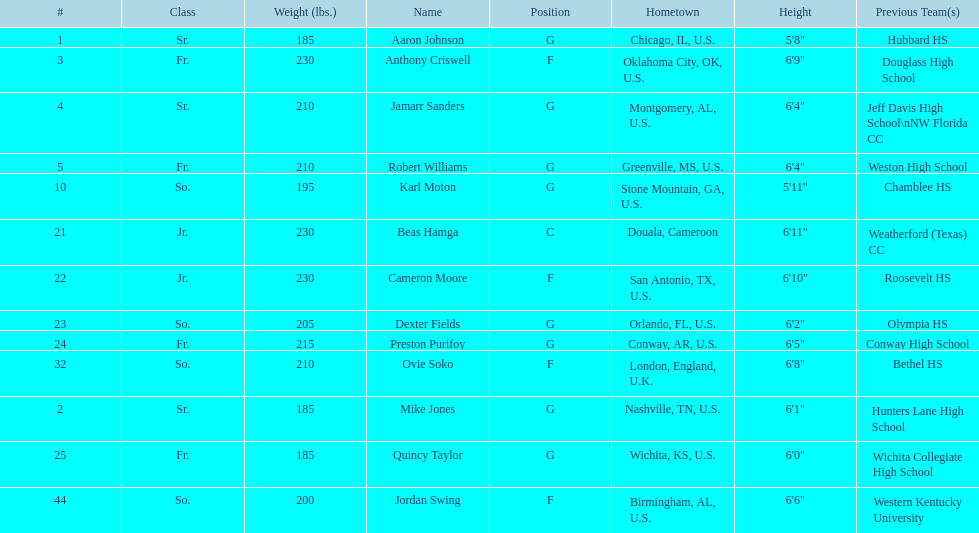How many players come from alabama? 2. 